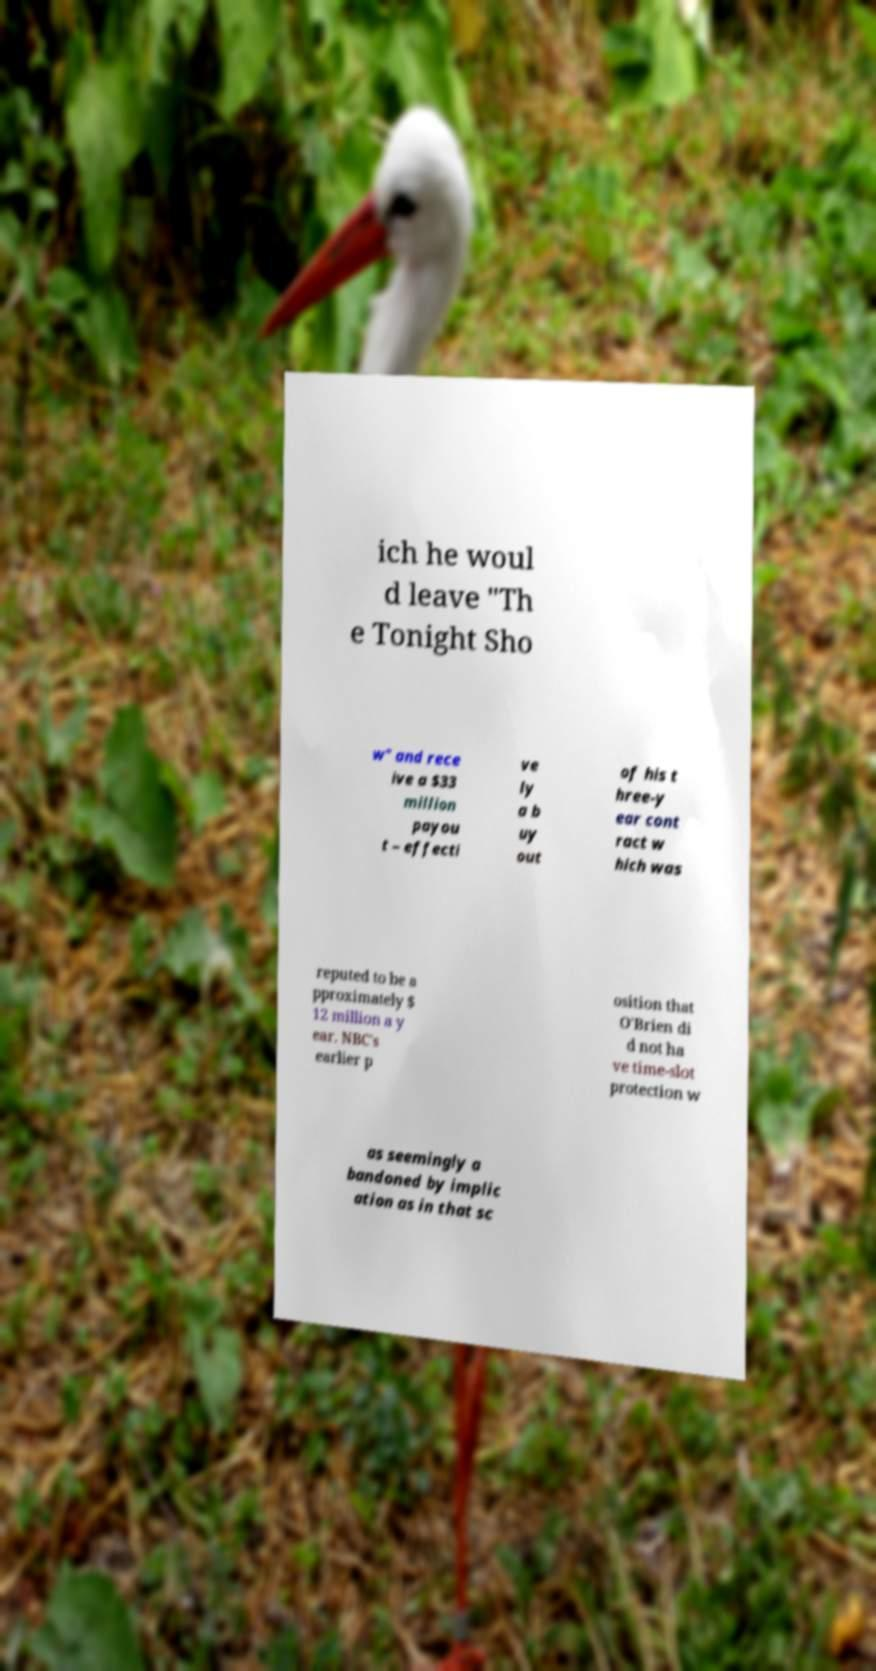What messages or text are displayed in this image? I need them in a readable, typed format. ich he woul d leave "Th e Tonight Sho w" and rece ive a $33 million payou t – effecti ve ly a b uy out of his t hree-y ear cont ract w hich was reputed to be a pproximately $ 12 million a y ear. NBC's earlier p osition that O'Brien di d not ha ve time-slot protection w as seemingly a bandoned by implic ation as in that sc 